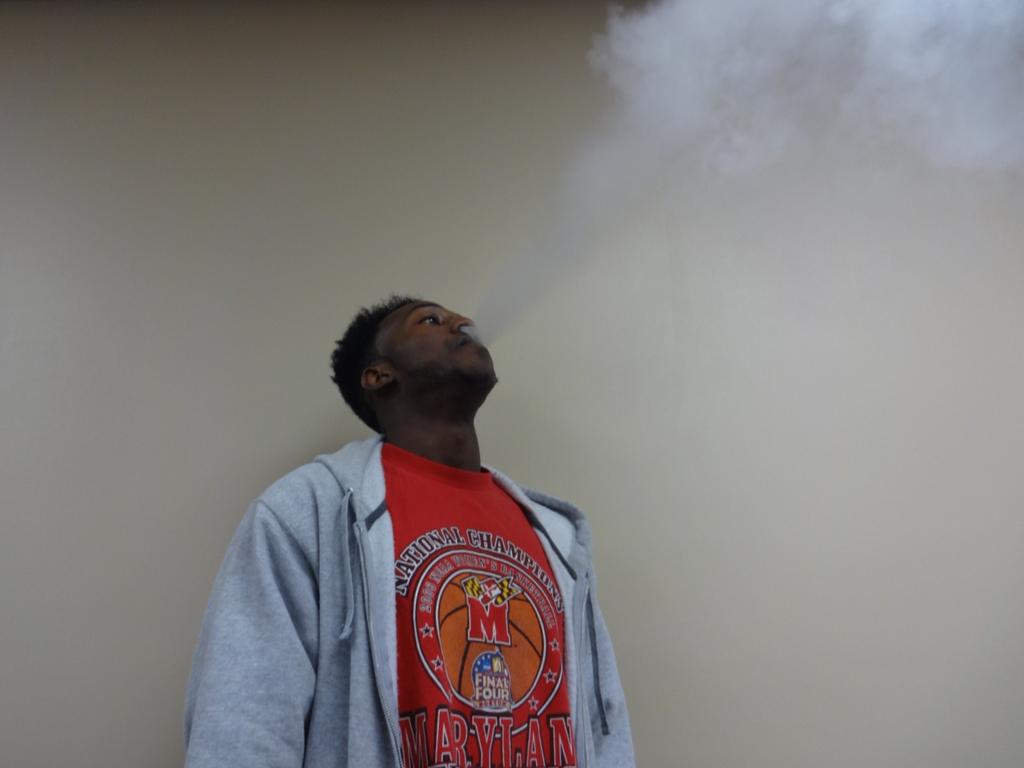What is the red letter in the center?
Keep it short and to the point. M. 